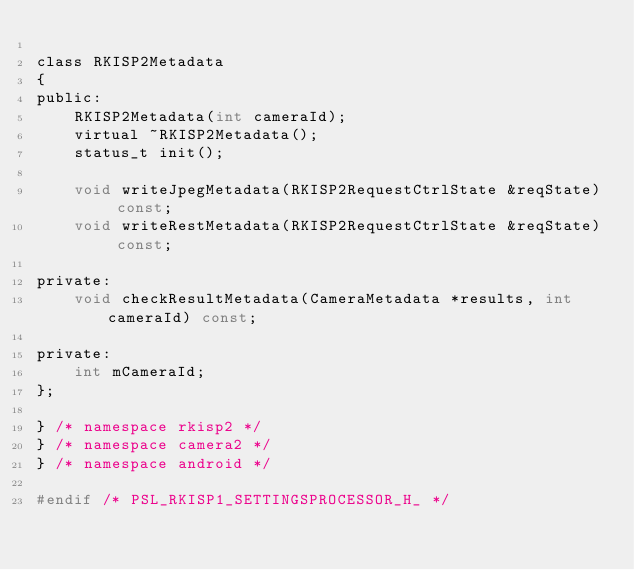<code> <loc_0><loc_0><loc_500><loc_500><_C_>
class RKISP2Metadata
{
public:
    RKISP2Metadata(int cameraId);
    virtual ~RKISP2Metadata();
    status_t init();

    void writeJpegMetadata(RKISP2RequestCtrlState &reqState) const;
    void writeRestMetadata(RKISP2RequestCtrlState &reqState) const;

private:
    void checkResultMetadata(CameraMetadata *results, int cameraId) const;

private:
    int mCameraId;
};

} /* namespace rkisp2 */
} /* namespace camera2 */
} /* namespace android */

#endif /* PSL_RKISP1_SETTINGSPROCESSOR_H_ */
</code> 